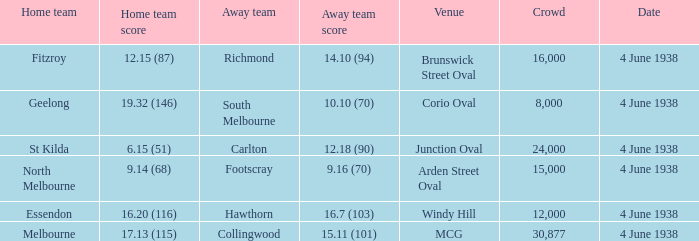How many attended the game at Arden Street Oval? 15000.0. 